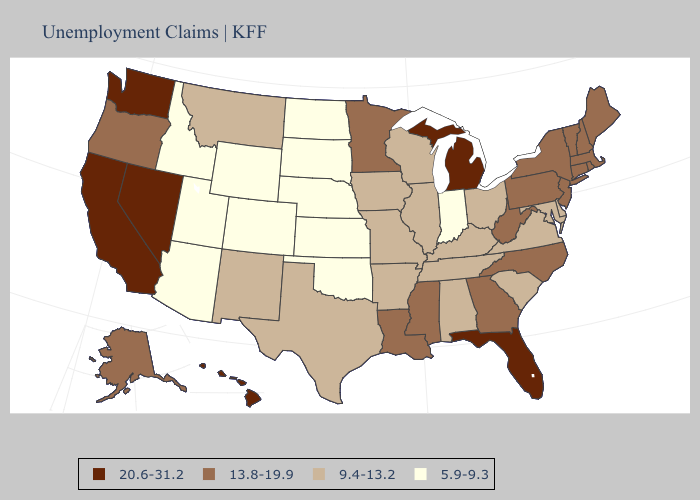Does California have the highest value in the USA?
Answer briefly. Yes. What is the lowest value in the Northeast?
Quick response, please. 13.8-19.9. What is the highest value in the MidWest ?
Keep it brief. 20.6-31.2. Does Indiana have the highest value in the USA?
Concise answer only. No. Does Michigan have the highest value in the MidWest?
Answer briefly. Yes. What is the highest value in states that border New Mexico?
Write a very short answer. 9.4-13.2. Does Hawaii have a lower value than South Carolina?
Write a very short answer. No. Name the states that have a value in the range 13.8-19.9?
Write a very short answer. Alaska, Connecticut, Georgia, Louisiana, Maine, Massachusetts, Minnesota, Mississippi, New Hampshire, New Jersey, New York, North Carolina, Oregon, Pennsylvania, Rhode Island, Vermont, West Virginia. Is the legend a continuous bar?
Quick response, please. No. Which states have the highest value in the USA?
Short answer required. California, Florida, Hawaii, Michigan, Nevada, Washington. Name the states that have a value in the range 9.4-13.2?
Keep it brief. Alabama, Arkansas, Delaware, Illinois, Iowa, Kentucky, Maryland, Missouri, Montana, New Mexico, Ohio, South Carolina, Tennessee, Texas, Virginia, Wisconsin. What is the value of West Virginia?
Answer briefly. 13.8-19.9. Which states hav the highest value in the West?
Answer briefly. California, Hawaii, Nevada, Washington. Does North Carolina have the lowest value in the South?
Give a very brief answer. No. What is the value of Nebraska?
Be succinct. 5.9-9.3. 